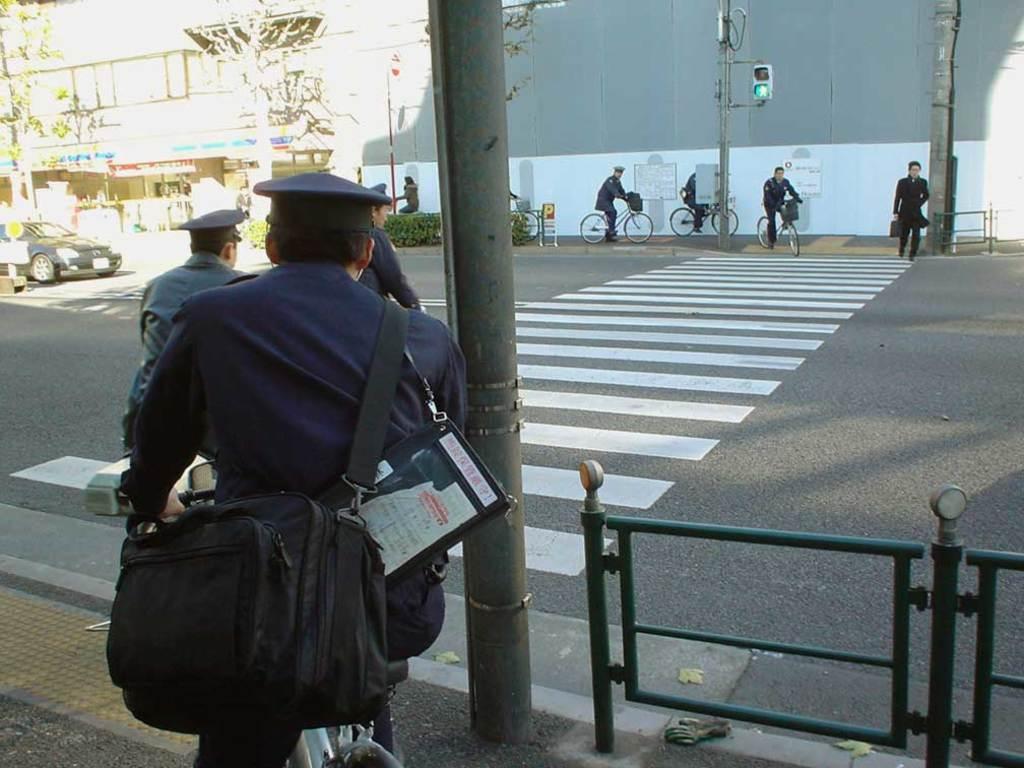Can you describe this image briefly? In the picture we can see a part of the path and on it we can see a man sitting on the bicycle near the pole and railing and beside it, we can see a road on it, we can see the zebra crossing and opposite side of the road we can see some people are riding their bicycles on the path and behind them we can see the wall and besides we can see the building with shops and near it we can see some poles with a traffic light and a part of the car on the road. 